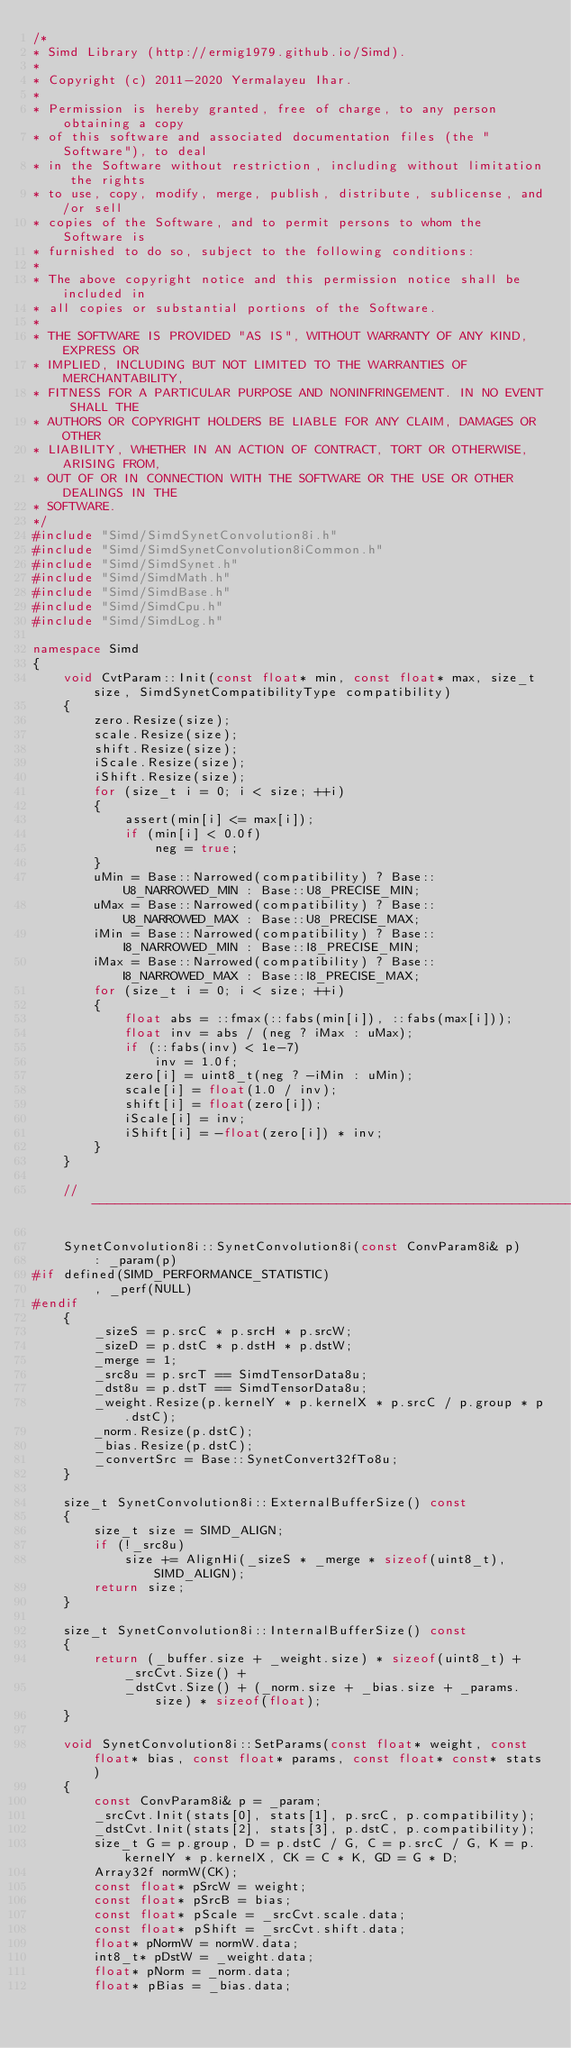<code> <loc_0><loc_0><loc_500><loc_500><_C++_>/*
* Simd Library (http://ermig1979.github.io/Simd).
*
* Copyright (c) 2011-2020 Yermalayeu Ihar.
*
* Permission is hereby granted, free of charge, to any person obtaining a copy
* of this software and associated documentation files (the "Software"), to deal
* in the Software without restriction, including without limitation the rights
* to use, copy, modify, merge, publish, distribute, sublicense, and/or sell
* copies of the Software, and to permit persons to whom the Software is
* furnished to do so, subject to the following conditions:
*
* The above copyright notice and this permission notice shall be included in
* all copies or substantial portions of the Software.
*
* THE SOFTWARE IS PROVIDED "AS IS", WITHOUT WARRANTY OF ANY KIND, EXPRESS OR
* IMPLIED, INCLUDING BUT NOT LIMITED TO THE WARRANTIES OF MERCHANTABILITY,
* FITNESS FOR A PARTICULAR PURPOSE AND NONINFRINGEMENT. IN NO EVENT SHALL THE
* AUTHORS OR COPYRIGHT HOLDERS BE LIABLE FOR ANY CLAIM, DAMAGES OR OTHER
* LIABILITY, WHETHER IN AN ACTION OF CONTRACT, TORT OR OTHERWISE, ARISING FROM,
* OUT OF OR IN CONNECTION WITH THE SOFTWARE OR THE USE OR OTHER DEALINGS IN THE
* SOFTWARE.
*/
#include "Simd/SimdSynetConvolution8i.h"
#include "Simd/SimdSynetConvolution8iCommon.h"
#include "Simd/SimdSynet.h"
#include "Simd/SimdMath.h"
#include "Simd/SimdBase.h"
#include "Simd/SimdCpu.h"
#include "Simd/SimdLog.h"

namespace Simd
{
    void CvtParam::Init(const float* min, const float* max, size_t size, SimdSynetCompatibilityType compatibility)
    {
        zero.Resize(size);
        scale.Resize(size);
        shift.Resize(size);
        iScale.Resize(size);
        iShift.Resize(size);
        for (size_t i = 0; i < size; ++i)
        {
            assert(min[i] <= max[i]);
            if (min[i] < 0.0f)
                neg = true;
        }
        uMin = Base::Narrowed(compatibility) ? Base::U8_NARROWED_MIN : Base::U8_PRECISE_MIN;
        uMax = Base::Narrowed(compatibility) ? Base::U8_NARROWED_MAX : Base::U8_PRECISE_MAX;
        iMin = Base::Narrowed(compatibility) ? Base::I8_NARROWED_MIN : Base::I8_PRECISE_MIN;
        iMax = Base::Narrowed(compatibility) ? Base::I8_NARROWED_MAX : Base::I8_PRECISE_MAX;
        for (size_t i = 0; i < size; ++i)
        {
            float abs = ::fmax(::fabs(min[i]), ::fabs(max[i]));
            float inv = abs / (neg ? iMax : uMax);
            if (::fabs(inv) < 1e-7)
                inv = 1.0f;
            zero[i] = uint8_t(neg ? -iMin : uMin);
            scale[i] = float(1.0 / inv);
            shift[i] = float(zero[i]);
            iScale[i] = inv;
            iShift[i] = -float(zero[i]) * inv;
        }
    }

    //-------------------------------------------------------------------------

    SynetConvolution8i::SynetConvolution8i(const ConvParam8i& p)
        : _param(p)
#if defined(SIMD_PERFORMANCE_STATISTIC)
        , _perf(NULL)
#endif
    {
        _sizeS = p.srcC * p.srcH * p.srcW;
        _sizeD = p.dstC * p.dstH * p.dstW;
        _merge = 1;
        _src8u = p.srcT == SimdTensorData8u;
        _dst8u = p.dstT == SimdTensorData8u;
        _weight.Resize(p.kernelY * p.kernelX * p.srcC / p.group * p.dstC);
        _norm.Resize(p.dstC);
        _bias.Resize(p.dstC);
        _convertSrc = Base::SynetConvert32fTo8u;
    }

    size_t SynetConvolution8i::ExternalBufferSize() const
    {
        size_t size = SIMD_ALIGN;
        if (!_src8u)
            size += AlignHi(_sizeS * _merge * sizeof(uint8_t), SIMD_ALIGN);
        return size;
    }

    size_t SynetConvolution8i::InternalBufferSize() const
    {
        return (_buffer.size + _weight.size) * sizeof(uint8_t) + _srcCvt.Size() + 
            _dstCvt.Size() + (_norm.size + _bias.size + _params.size) * sizeof(float);
    }

    void SynetConvolution8i::SetParams(const float* weight, const float* bias, const float* params, const float* const* stats)
    {
        const ConvParam8i& p = _param;
        _srcCvt.Init(stats[0], stats[1], p.srcC, p.compatibility);
        _dstCvt.Init(stats[2], stats[3], p.dstC, p.compatibility);
        size_t G = p.group, D = p.dstC / G, C = p.srcC / G, K = p.kernelY * p.kernelX, CK = C * K, GD = G * D;
        Array32f normW(CK);
        const float* pSrcW = weight;
        const float* pSrcB = bias;
        const float* pScale = _srcCvt.scale.data;
        const float* pShift = _srcCvt.shift.data;
        float* pNormW = normW.data;
        int8_t* pDstW = _weight.data;
        float* pNorm = _norm.data;
        float* pBias = _bias.data;</code> 